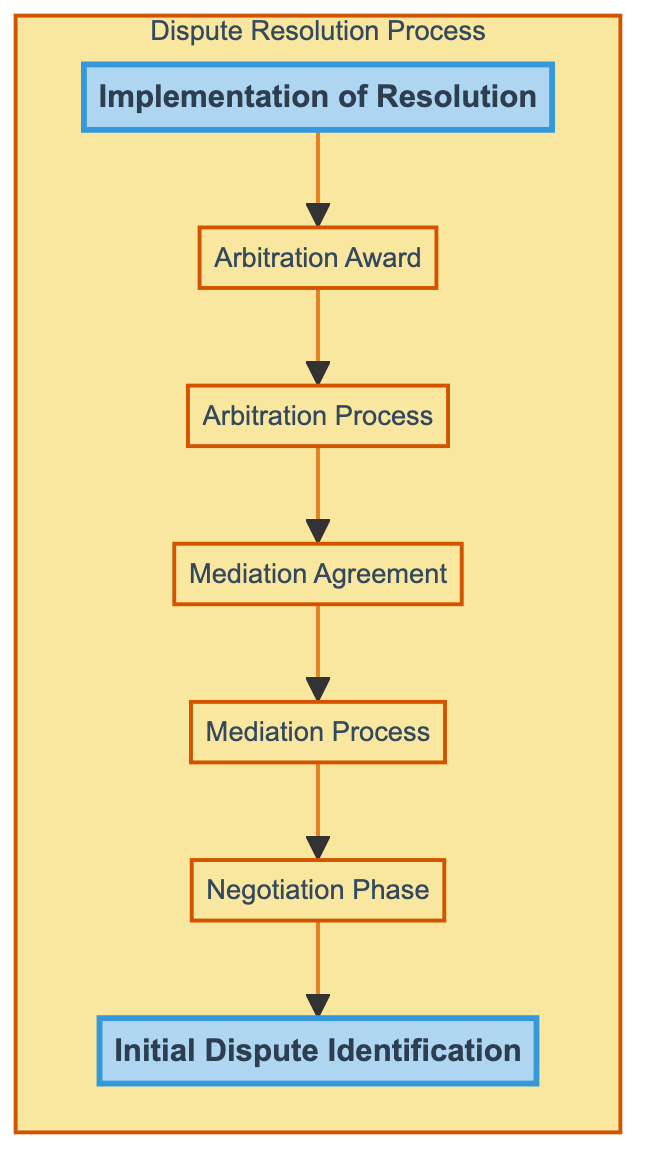What is the first stage in the dispute resolution process? The first stage is "Initial Dispute Identification," which is directly indicated at the bottom of the flow chart. This stage identifies the fundamental issue or conflict in cannabis operations or agreements.
Answer: Initial Dispute Identification Which stage comes immediately after the "Negotiation Phase"? The stage that follows the "Negotiation Phase" is the "Mediation Process." This relationship can be traced by observing the flow of the diagram moving upwards.
Answer: Mediation Process How many total stages are shown in the diagram? There are a total of seven stages depicted in the flow chart. Counting the nodes visually confirms this number.
Answer: Seven What type of resolution is legally binding? The "Arbitration Award" is identified as the legally binding resolution in this process, specifically marked as the result of the arbitration.
Answer: Arbitration Award What is documented in the "Mediation Agreement"? The "Mediation Agreement" documents the resolution that the parties agreed upon with the mediator's guidance. This is explicitly stated within the diagram's description for the node.
Answer: Resolution Which two stages are highlighted in the diagram? The two highlighted stages are "Implementation of Resolution" and "Initial Dispute Identification." These are emphasized visually within the diagram through distinct styles.
Answer: Implementation of Resolution and Initial Dispute Identification What is the main function of the "Arbitration Process"? The role of the "Arbitration Process" is to enable a neutral arbitrator to hear both sides and deliver a binding decision. This function is detailed in the description associated with that node.
Answer: Hear both sides What stage follows "Mediation Process" leading to an agreed resolution? The "Mediation Agreement" follows the "Mediation Process," as it represents the outcome of that stage where a resolution is documented.
Answer: Mediation Agreement What does the flow from "Arbitration Award" to "Implementation of Resolution" signify? The flow indicates that the arbitration award leads directly to the implementation of the resolution, showing that the binding decision requires action by the parties involved to integrate the outcome into their operations.
Answer: Implementation of Resolution 